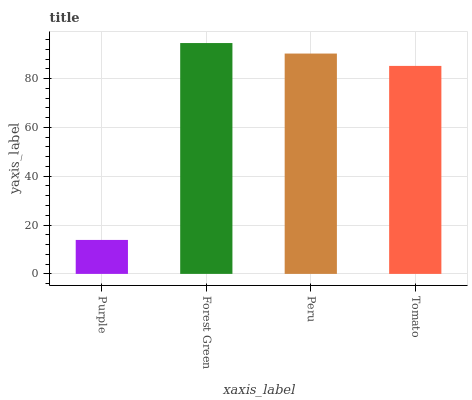Is Purple the minimum?
Answer yes or no. Yes. Is Forest Green the maximum?
Answer yes or no. Yes. Is Peru the minimum?
Answer yes or no. No. Is Peru the maximum?
Answer yes or no. No. Is Forest Green greater than Peru?
Answer yes or no. Yes. Is Peru less than Forest Green?
Answer yes or no. Yes. Is Peru greater than Forest Green?
Answer yes or no. No. Is Forest Green less than Peru?
Answer yes or no. No. Is Peru the high median?
Answer yes or no. Yes. Is Tomato the low median?
Answer yes or no. Yes. Is Purple the high median?
Answer yes or no. No. Is Forest Green the low median?
Answer yes or no. No. 